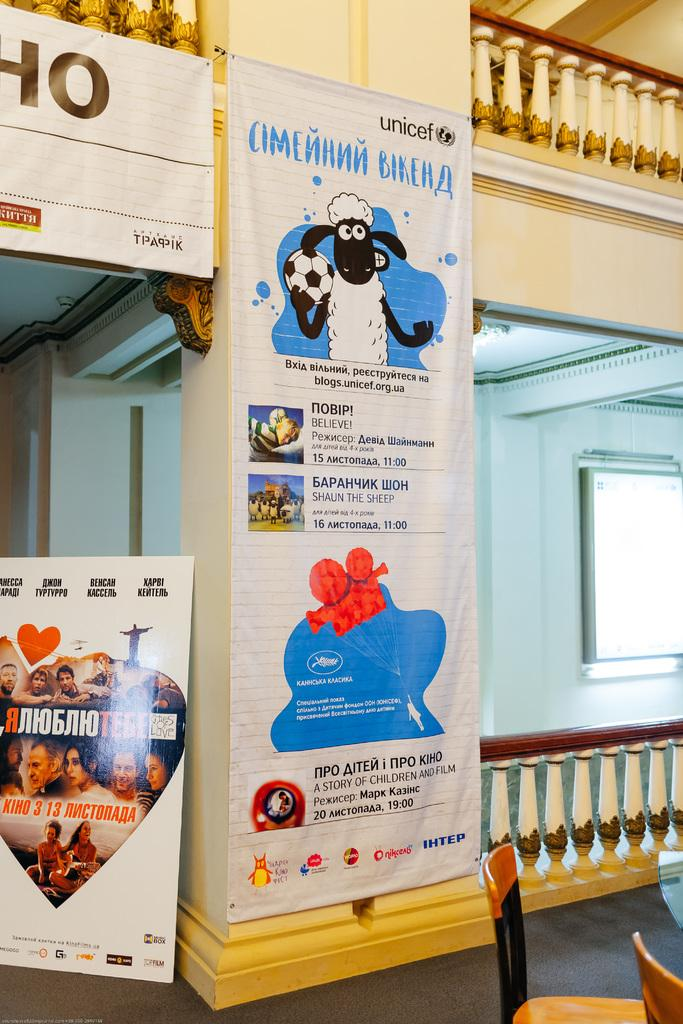What is hanging from the ceiling in the image? There are banners in the image. What can be seen on the banners? The banners have pictures on them and text written on them. What type of furniture is present in the image? There are chairs in the image. What part of the room can be seen in the image? The floor is visible in the image. What is visible in the background of the image? There is a wall in the background of the image. Where is the coast located in the image? There is no coast present in the image. What type of wheel can be seen on the banners? There are no wheels depicted on the banners in the image. 